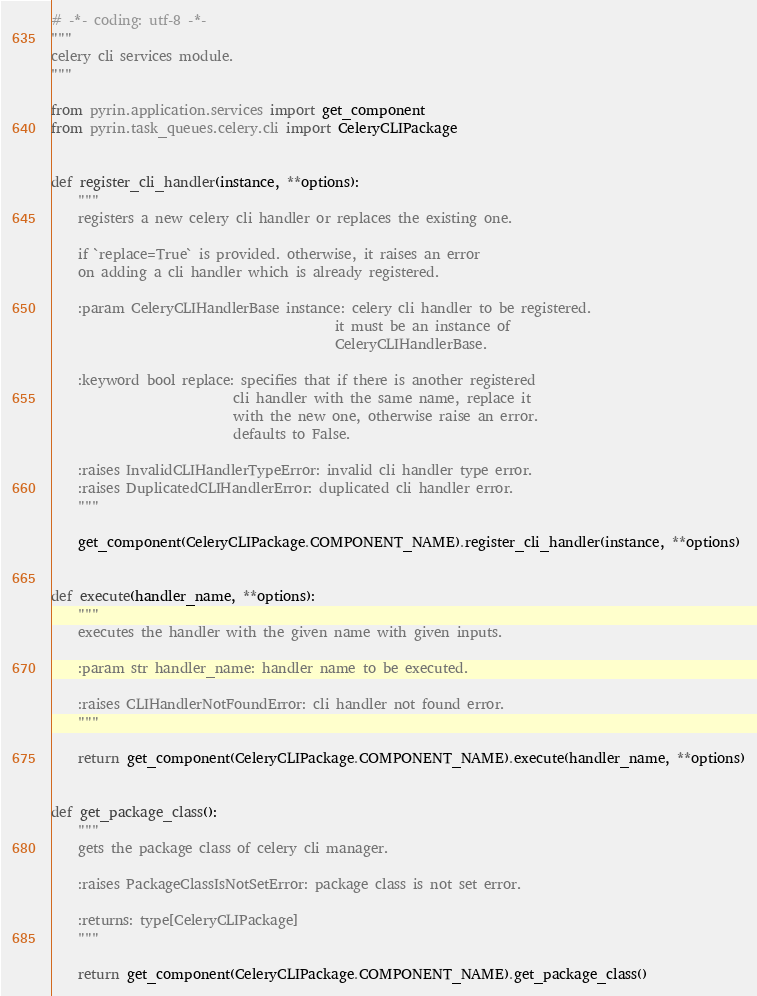<code> <loc_0><loc_0><loc_500><loc_500><_Python_># -*- coding: utf-8 -*-
"""
celery cli services module.
"""

from pyrin.application.services import get_component
from pyrin.task_queues.celery.cli import CeleryCLIPackage


def register_cli_handler(instance, **options):
    """
    registers a new celery cli handler or replaces the existing one.

    if `replace=True` is provided. otherwise, it raises an error
    on adding a cli handler which is already registered.

    :param CeleryCLIHandlerBase instance: celery cli handler to be registered.
                                          it must be an instance of
                                          CeleryCLIHandlerBase.

    :keyword bool replace: specifies that if there is another registered
                           cli handler with the same name, replace it
                           with the new one, otherwise raise an error.
                           defaults to False.

    :raises InvalidCLIHandlerTypeError: invalid cli handler type error.
    :raises DuplicatedCLIHandlerError: duplicated cli handler error.
    """

    get_component(CeleryCLIPackage.COMPONENT_NAME).register_cli_handler(instance, **options)


def execute(handler_name, **options):
    """
    executes the handler with the given name with given inputs.

    :param str handler_name: handler name to be executed.

    :raises CLIHandlerNotFoundError: cli handler not found error.
    """

    return get_component(CeleryCLIPackage.COMPONENT_NAME).execute(handler_name, **options)


def get_package_class():
    """
    gets the package class of celery cli manager.

    :raises PackageClassIsNotSetError: package class is not set error.

    :returns: type[CeleryCLIPackage]
    """

    return get_component(CeleryCLIPackage.COMPONENT_NAME).get_package_class()
</code> 